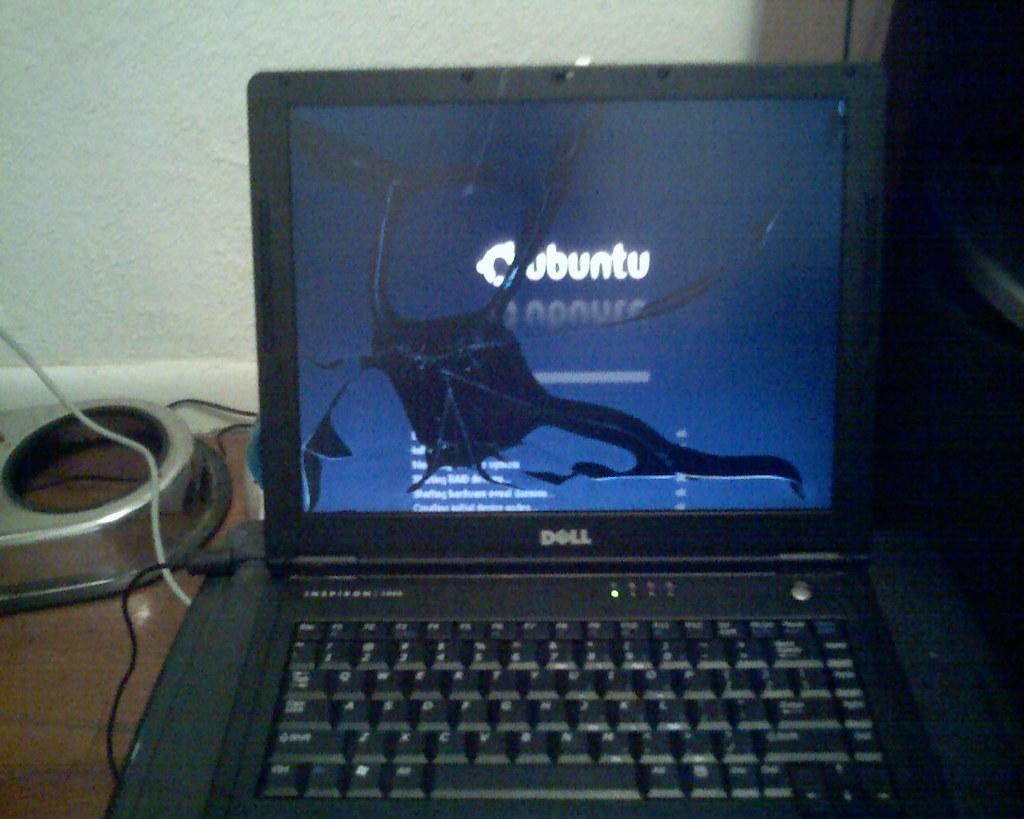<image>
Render a clear and concise summary of the photo. Dell laptop with a monitor that says Ubuntu. 